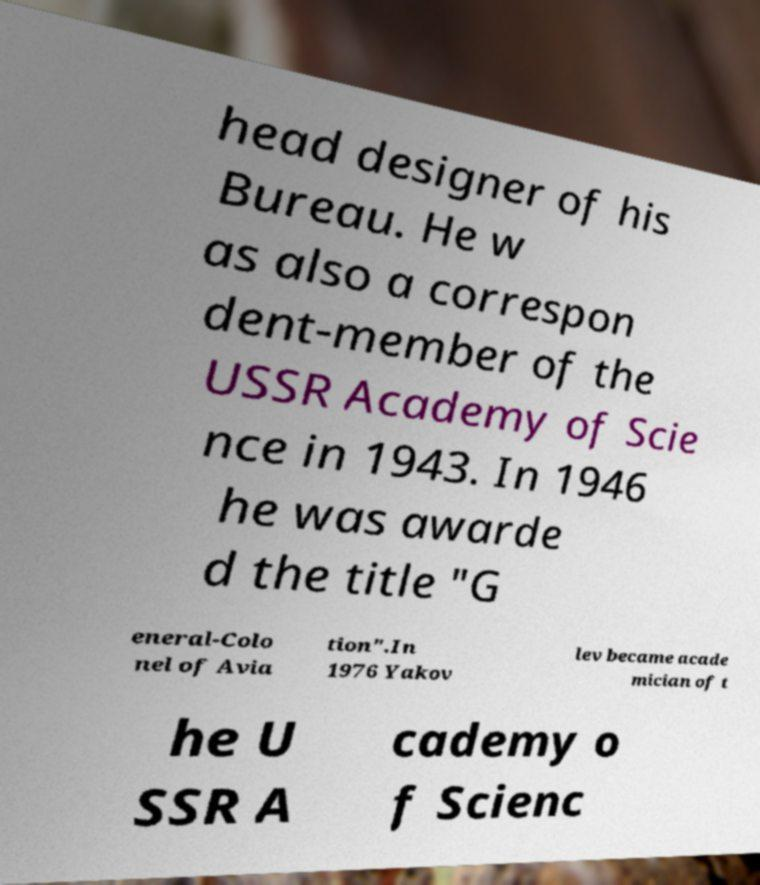What messages or text are displayed in this image? I need them in a readable, typed format. head designer of his Bureau. He w as also a correspon dent-member of the USSR Academy of Scie nce in 1943. In 1946 he was awarde d the title "G eneral-Colo nel of Avia tion".In 1976 Yakov lev became acade mician of t he U SSR A cademy o f Scienc 